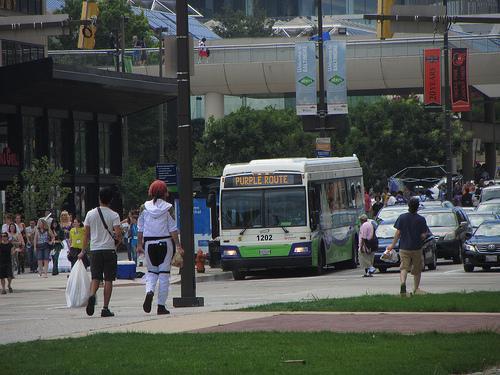How many busses are in the scene?
Give a very brief answer. 1. 